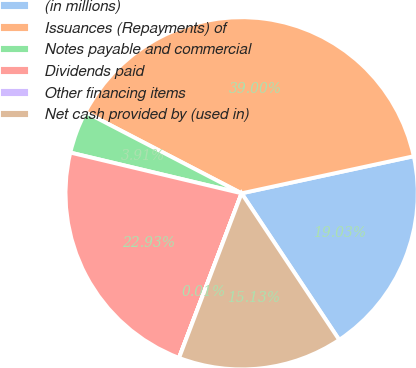Convert chart. <chart><loc_0><loc_0><loc_500><loc_500><pie_chart><fcel>(in millions)<fcel>Issuances (Repayments) of<fcel>Notes payable and commercial<fcel>Dividends paid<fcel>Other financing items<fcel>Net cash provided by (used in)<nl><fcel>19.03%<fcel>39.0%<fcel>3.91%<fcel>22.93%<fcel>0.01%<fcel>15.13%<nl></chart> 